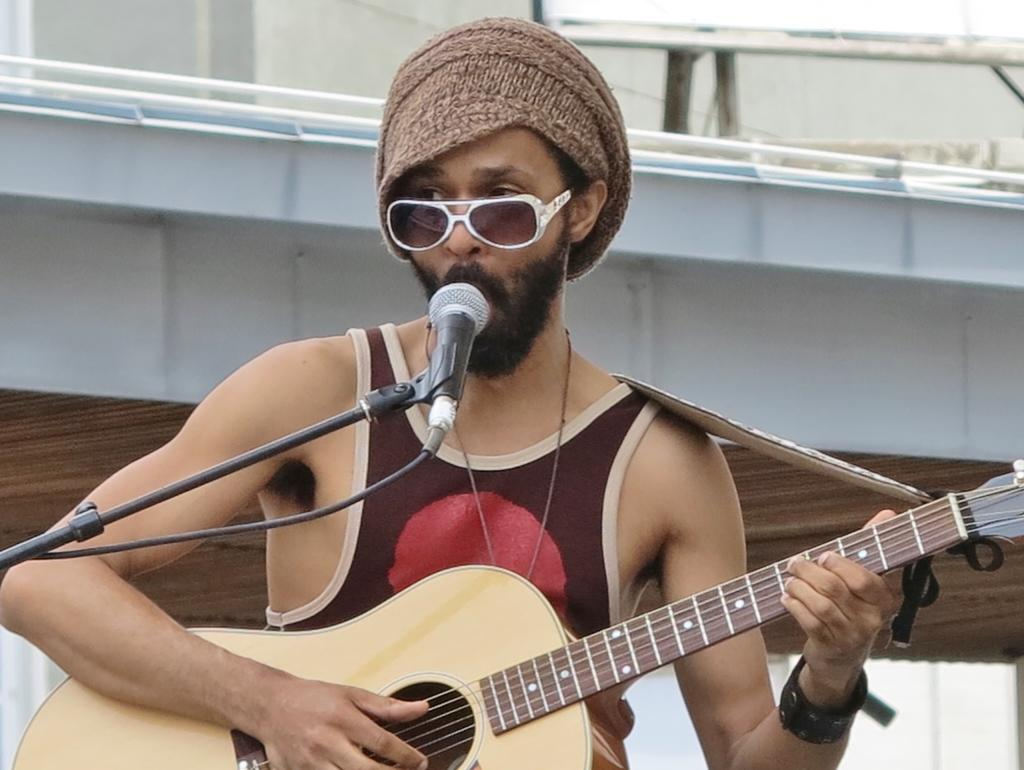Who is the main subject in the image? There is a man in the image. What is the man holding in the image? The man is holding a guitar. What object is in front of the man that might be used for amplifying his voice? There is a microphone with a stand in front of the man. What type of watch is the man wearing in the image? There is no watch visible on the man in the image. What kind of sports field is shown in the background of the image? There is no sports field present in the image; it only features the man, the guitar, and the microphone with a stand. 